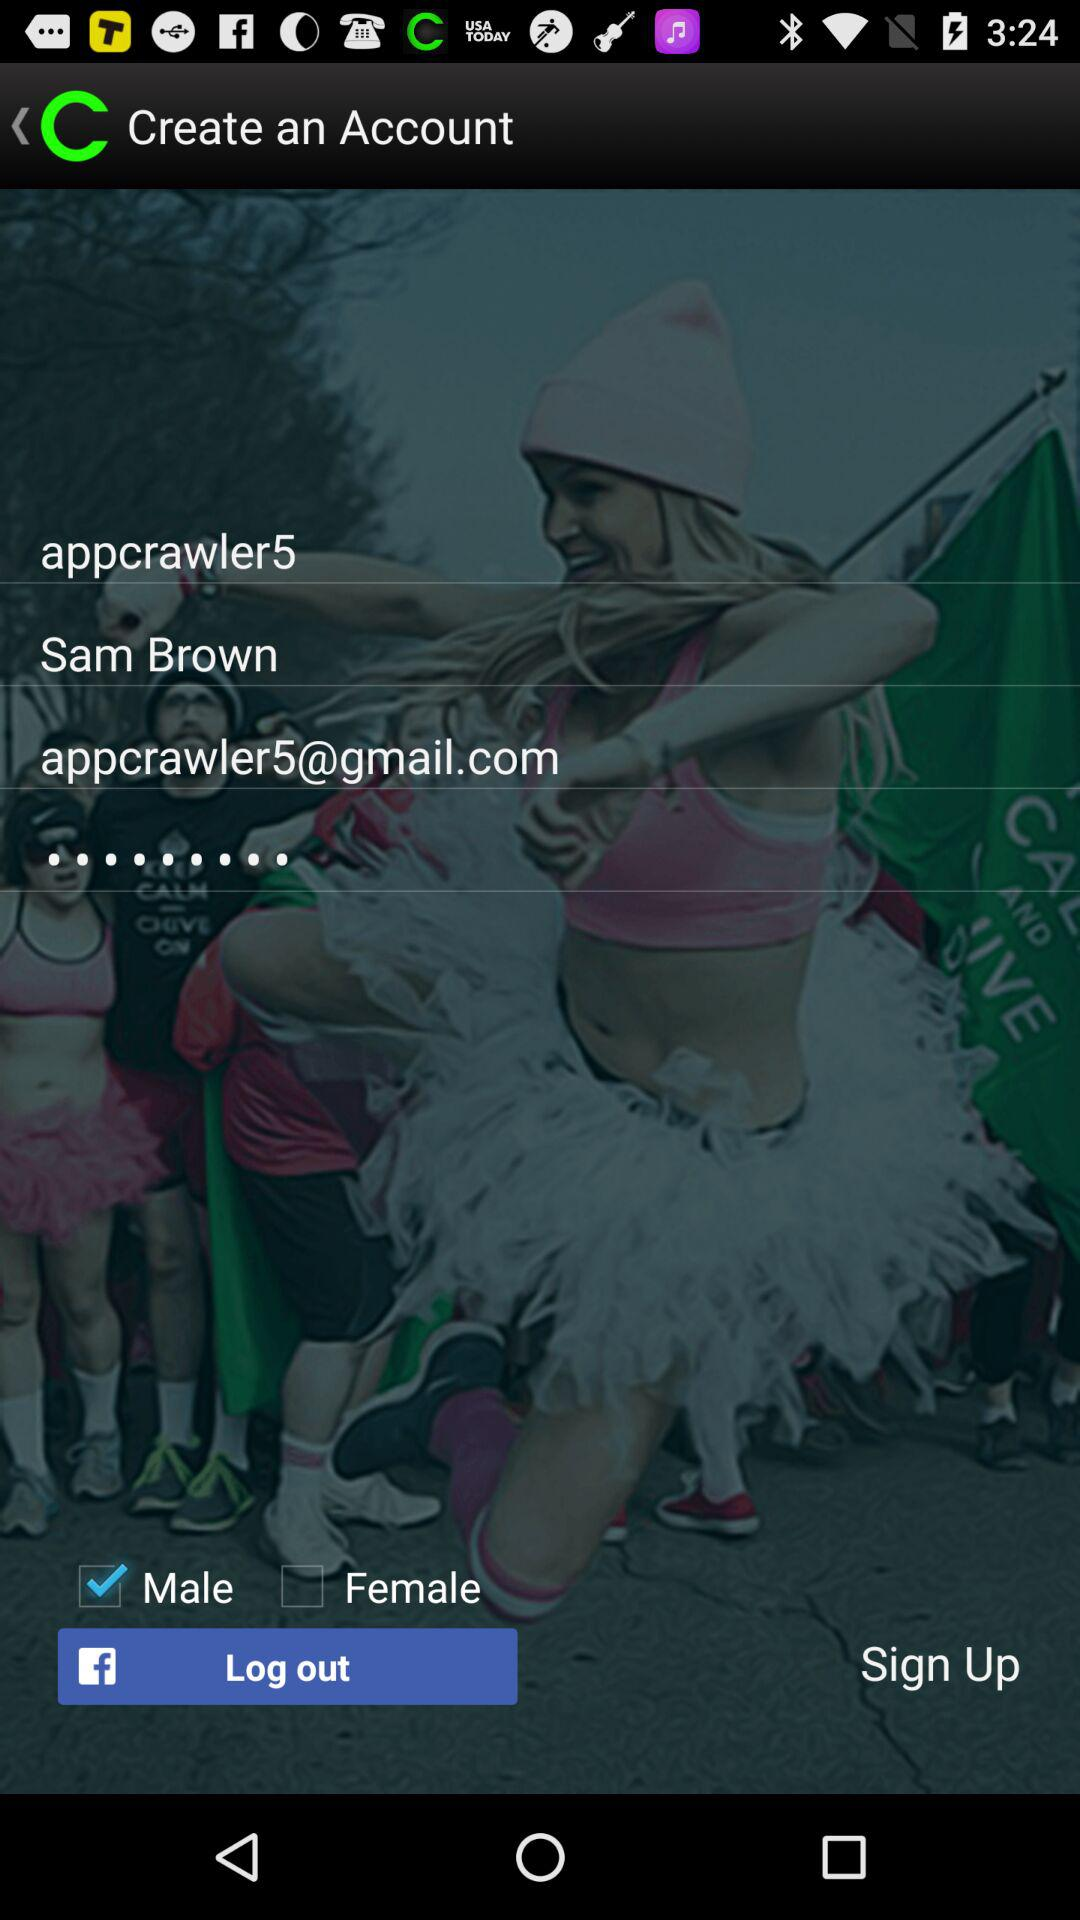What is user identification? The user identification is appcrawler5. 